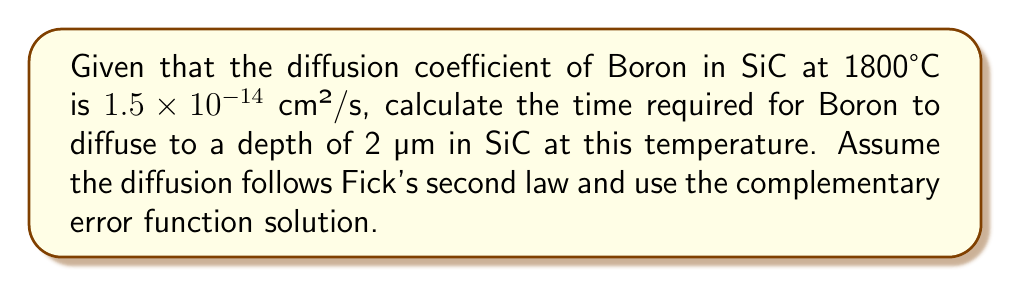Can you solve this math problem? To solve this problem, we'll use the solution to Fick's second law for a semi-infinite medium with a constant surface concentration:

$$C(x,t) = C_s \cdot \text{erfc}\left(\frac{x}{2\sqrt{Dt}}\right)$$

Where:
- $C(x,t)$ is the concentration at depth $x$ and time $t$
- $C_s$ is the surface concentration
- $\text{erfc}$ is the complementary error function
- $D$ is the diffusion coefficient
- $x$ is the depth
- $t$ is the time

We want to find the time when the concentration at a depth of 2 µm (or $2 \times 10^{-4}$ cm) is about 50% of the surface concentration. This occurs when the argument of erfc is approximately 0.5:

$$\frac{x}{2\sqrt{Dt}} \approx 0.5$$

Now, let's solve for $t$:

1) First, square both sides:
   $$\left(\frac{x}{2\sqrt{Dt}}\right)^2 = (0.5)^2 = 0.25$$

2) Simplify:
   $$\frac{x^2}{4Dt} = 0.25$$

3) Multiply both sides by $4Dt$:
   $$x^2 = Dt$$

4) Solve for $t$:
   $$t = \frac{x^2}{D}$$

5) Now, let's substitute our values:
   $x = 2 \times 10^{-4}$ cm
   $D = 1.5 \times 10^{-14}$ cm²/s

   $$t = \frac{(2 \times 10^{-4})^2}{1.5 \times 10^{-14}}$$

6) Calculate:
   $$t = \frac{4 \times 10^{-8}}{1.5 \times 10^{-14}} = 2.67 \times 10^6 \text{ seconds}$$

7) Convert to hours:
   $$t = \frac{2.67 \times 10^6}{3600} \approx 741 \text{ hours}$$
Answer: 741 hours 